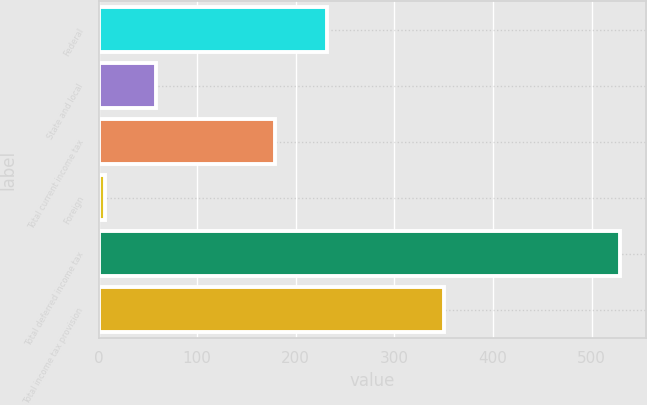Convert chart to OTSL. <chart><loc_0><loc_0><loc_500><loc_500><bar_chart><fcel>Federal<fcel>State and local<fcel>Total current income tax<fcel>Foreign<fcel>Total deferred income tax<fcel>Total income tax provision<nl><fcel>231.3<fcel>58.3<fcel>179<fcel>6<fcel>529<fcel>350<nl></chart> 